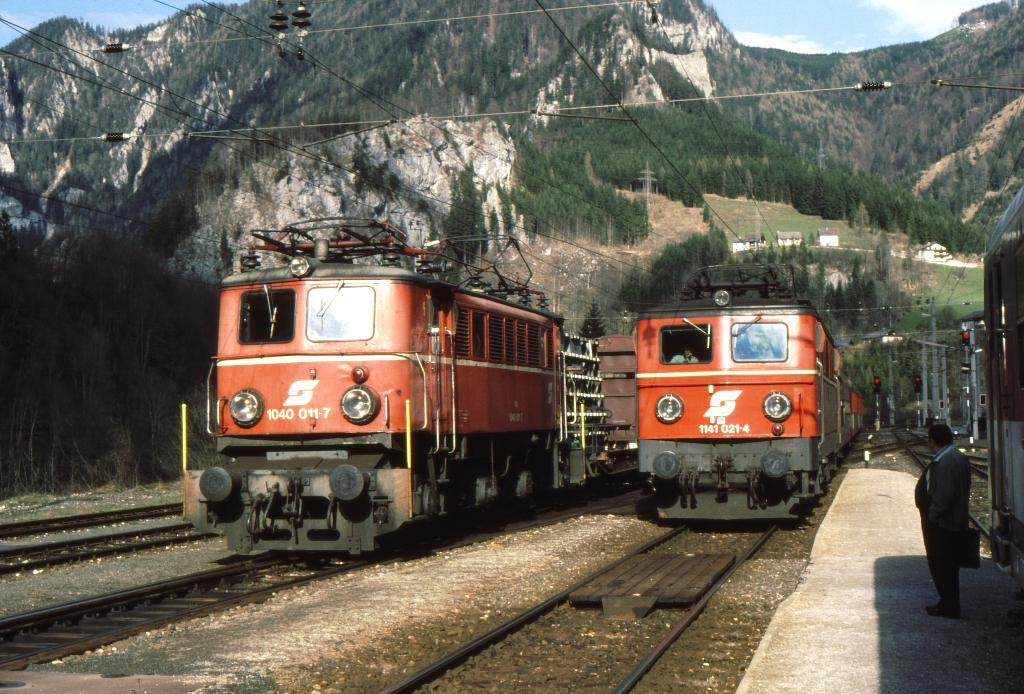<image>
Write a terse but informative summary of the picture. the numbers 1141 that are on the train 